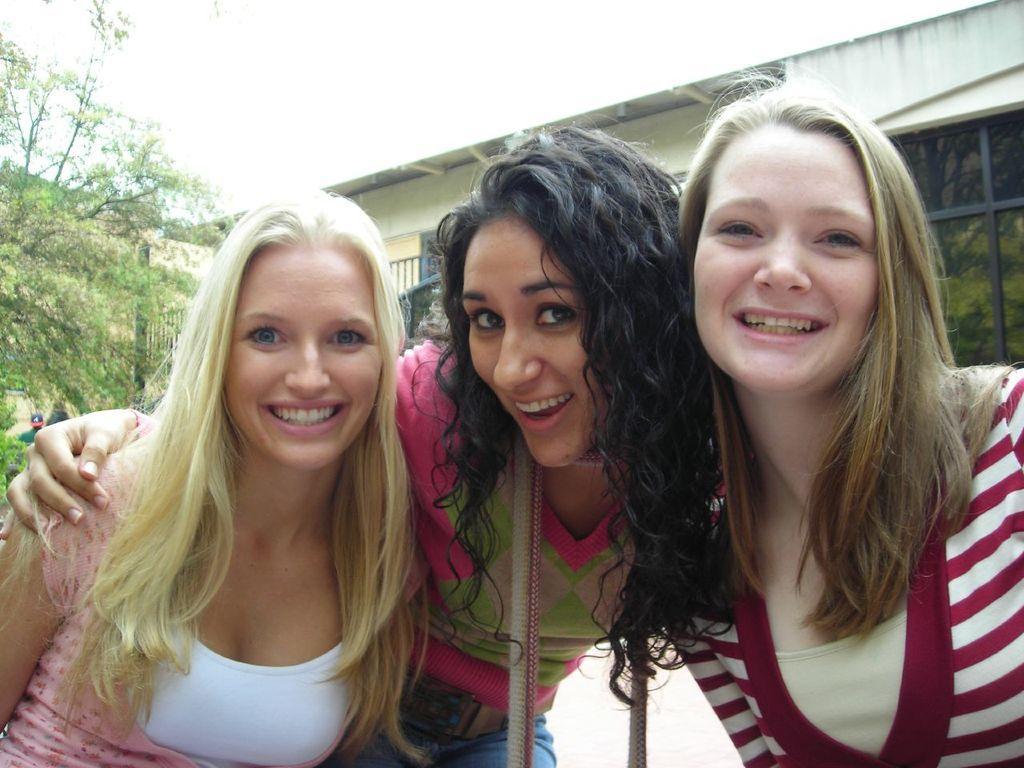How would you summarize this image in a sentence or two? There are three women holding each other and there is a building and a tree in the background. 